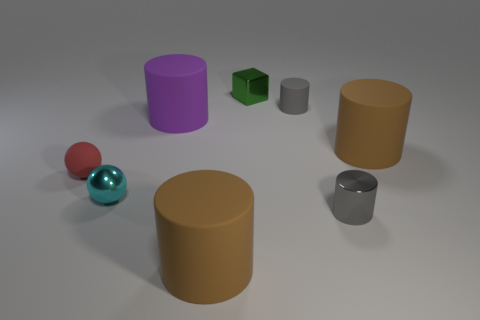There is a large brown cylinder in front of the small red object; what material is it?
Your answer should be compact. Rubber. Does the gray matte object have the same shape as the tiny metal object that is on the right side of the green metal object?
Provide a succinct answer. Yes. Is the number of small yellow balls greater than the number of big purple rubber things?
Your response must be concise. No. Are there any other things that are the same color as the matte sphere?
Give a very brief answer. No. What is the shape of the small gray object that is the same material as the cube?
Ensure brevity in your answer.  Cylinder. What material is the gray cylinder behind the brown matte object on the right side of the green shiny object?
Offer a terse response. Rubber. There is a gray object on the right side of the small gray rubber thing; does it have the same shape as the green thing?
Your answer should be compact. No. Are there more big cylinders to the left of the purple object than gray metallic cylinders?
Offer a very short reply. No. Is there any other thing that is made of the same material as the cyan thing?
Give a very brief answer. Yes. How many blocks are either blue things or big purple rubber things?
Provide a short and direct response. 0. 